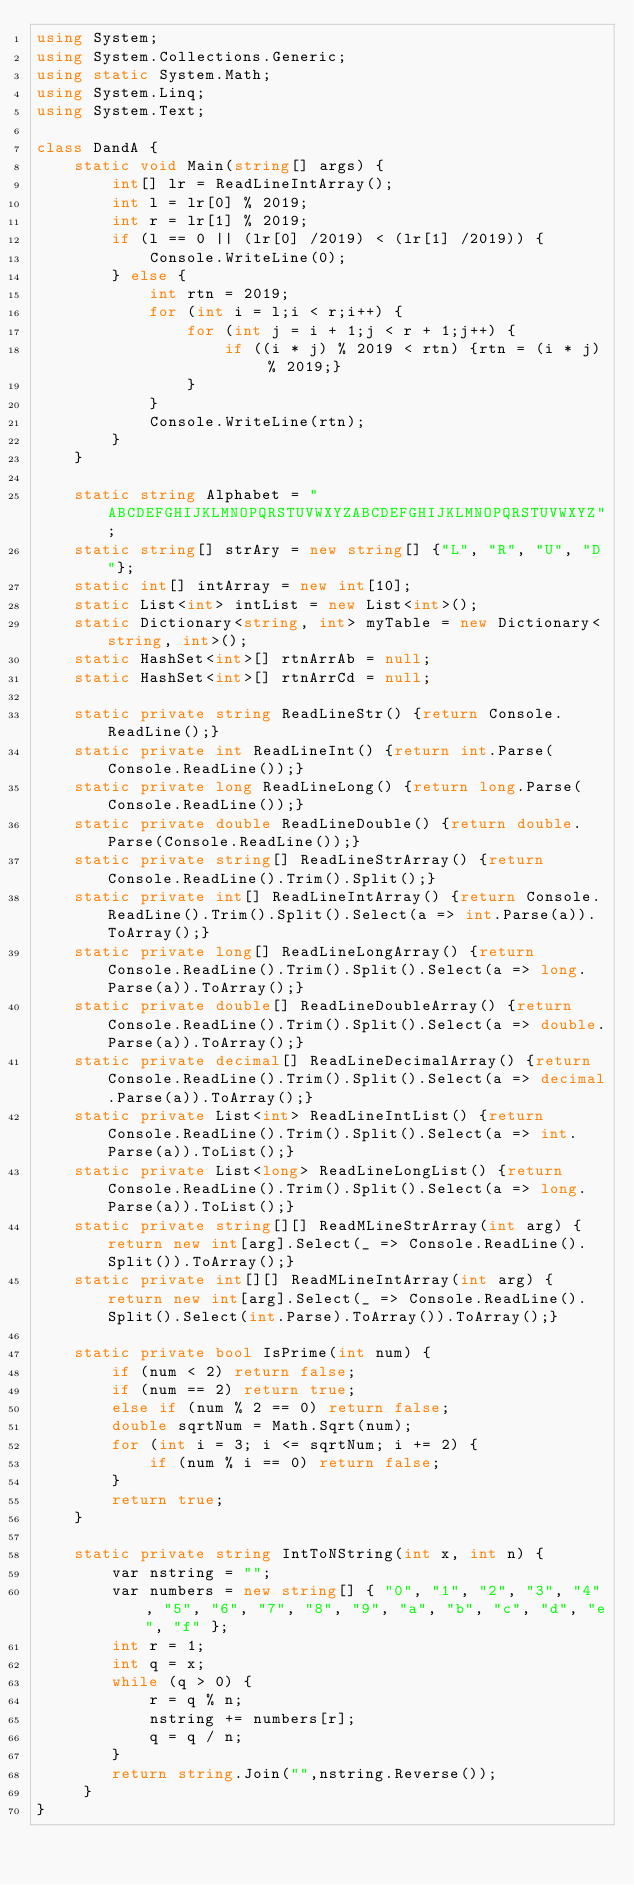<code> <loc_0><loc_0><loc_500><loc_500><_C#_>using System;
using System.Collections.Generic;
using static System.Math;
using System.Linq;
using System.Text;
 
class DandA {
    static void Main(string[] args) {
        int[] lr = ReadLineIntArray();
        int l = lr[0] % 2019;
        int r = lr[1] % 2019;
        if (l == 0 || (lr[0] /2019) < (lr[1] /2019)) {
            Console.WriteLine(0);
        } else {
            int rtn = 2019;
            for (int i = l;i < r;i++) {
                for (int j = i + 1;j < r + 1;j++) {
                    if ((i * j) % 2019 < rtn) {rtn = (i * j) % 2019;}
                }
            }
            Console.WriteLine(rtn);
        }
    }
 
    static string Alphabet = "ABCDEFGHIJKLMNOPQRSTUVWXYZABCDEFGHIJKLMNOPQRSTUVWXYZ";
    static string[] strAry = new string[] {"L", "R", "U", "D"};
    static int[] intArray = new int[10];
    static List<int> intList = new List<int>();
    static Dictionary<string, int> myTable = new Dictionary<string, int>();
    static HashSet<int>[] rtnArrAb = null;
    static HashSet<int>[] rtnArrCd = null;
  
    static private string ReadLineStr() {return Console.ReadLine();}
    static private int ReadLineInt() {return int.Parse(Console.ReadLine());}
    static private long ReadLineLong() {return long.Parse(Console.ReadLine());}
    static private double ReadLineDouble() {return double.Parse(Console.ReadLine());}
    static private string[] ReadLineStrArray() {return Console.ReadLine().Trim().Split();}
    static private int[] ReadLineIntArray() {return Console.ReadLine().Trim().Split().Select(a => int.Parse(a)).ToArray();}
    static private long[] ReadLineLongArray() {return Console.ReadLine().Trim().Split().Select(a => long.Parse(a)).ToArray();}
    static private double[] ReadLineDoubleArray() {return Console.ReadLine().Trim().Split().Select(a => double.Parse(a)).ToArray();}
    static private decimal[] ReadLineDecimalArray() {return Console.ReadLine().Trim().Split().Select(a => decimal.Parse(a)).ToArray();}
    static private List<int> ReadLineIntList() {return Console.ReadLine().Trim().Split().Select(a => int.Parse(a)).ToList();}
    static private List<long> ReadLineLongList() {return Console.ReadLine().Trim().Split().Select(a => long.Parse(a)).ToList();}
    static private string[][] ReadMLineStrArray(int arg) { return new int[arg].Select(_ => Console.ReadLine().Split()).ToArray();}
    static private int[][] ReadMLineIntArray(int arg) { return new int[arg].Select(_ => Console.ReadLine().Split().Select(int.Parse).ToArray()).ToArray();}
 
    static private bool IsPrime(int num) {
        if (num < 2) return false;
        if (num == 2) return true;
        else if (num % 2 == 0) return false;
        double sqrtNum = Math.Sqrt(num);
        for (int i = 3; i <= sqrtNum; i += 2) {
            if (num % i == 0) return false;
        }
        return true;
    }
  
    static private string IntToNString(int x, int n) {
        var nstring = "";
        var numbers = new string[] { "0", "1", "2", "3", "4", "5", "6", "7", "8", "9", "a", "b", "c", "d", "e", "f" };
        int r = 1;
        int q = x;
        while (q > 0) {
            r = q % n;
            nstring += numbers[r];
            q = q / n;
        }
        return string.Join("",nstring.Reverse());
     }
}</code> 